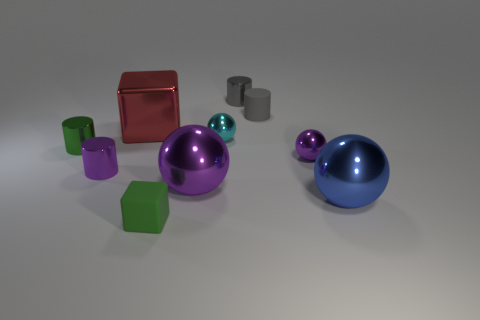Subtract 1 spheres. How many spheres are left? 3 Subtract all green cylinders. How many cylinders are left? 3 Subtract all shiny cylinders. How many cylinders are left? 1 Subtract all cubes. How many objects are left? 8 Subtract all big gray matte cylinders. Subtract all small cylinders. How many objects are left? 6 Add 2 green blocks. How many green blocks are left? 3 Add 6 big brown rubber blocks. How many big brown rubber blocks exist? 6 Subtract 0 brown cylinders. How many objects are left? 10 